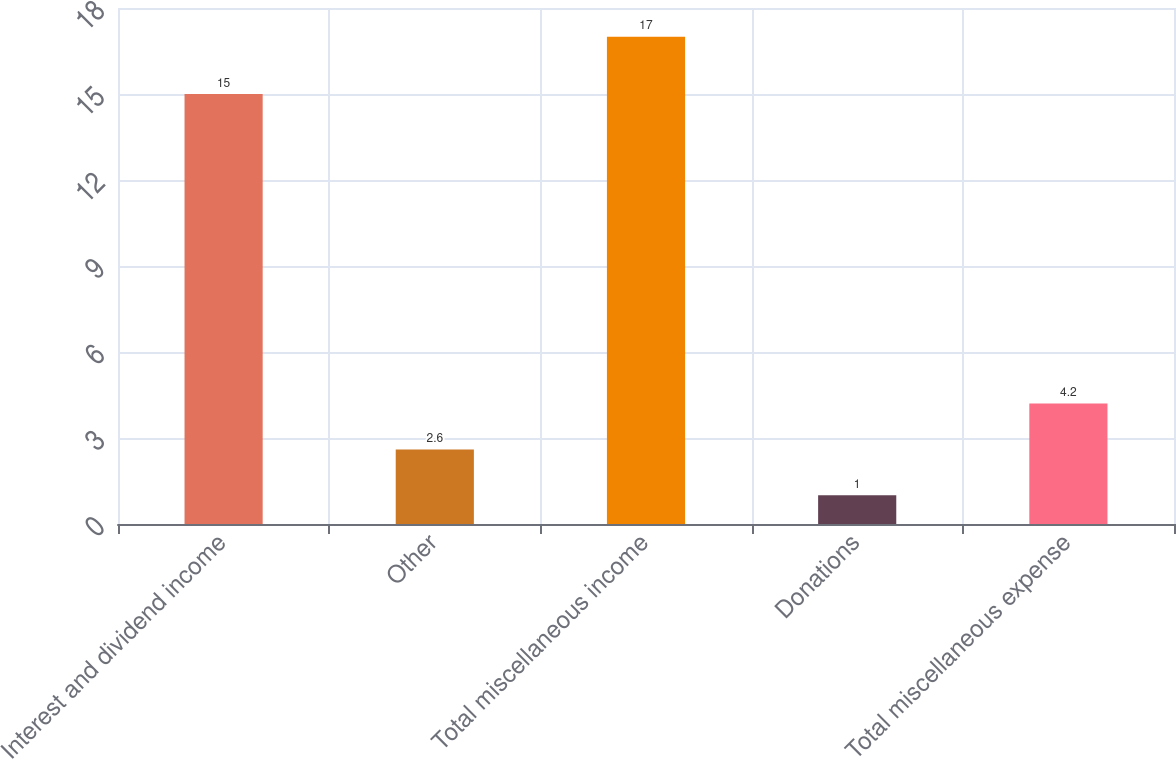Convert chart to OTSL. <chart><loc_0><loc_0><loc_500><loc_500><bar_chart><fcel>Interest and dividend income<fcel>Other<fcel>Total miscellaneous income<fcel>Donations<fcel>Total miscellaneous expense<nl><fcel>15<fcel>2.6<fcel>17<fcel>1<fcel>4.2<nl></chart> 